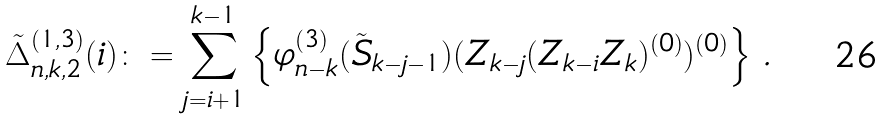Convert formula to latex. <formula><loc_0><loc_0><loc_500><loc_500>{ \tilde { \Delta } } _ { n , k , 2 } ^ { ( 1 , 3 ) } ( i ) \colon = \sum _ { j = i + 1 } ^ { k - 1 } \left \{ \varphi ^ { ( 3 ) } _ { n - k } ( \tilde { S } _ { k - j - 1 } ) ( Z _ { k - j } ( Z _ { k - i } Z _ { k } ) ^ { ( 0 ) } ) ^ { ( 0 ) } \right \} \, .</formula> 